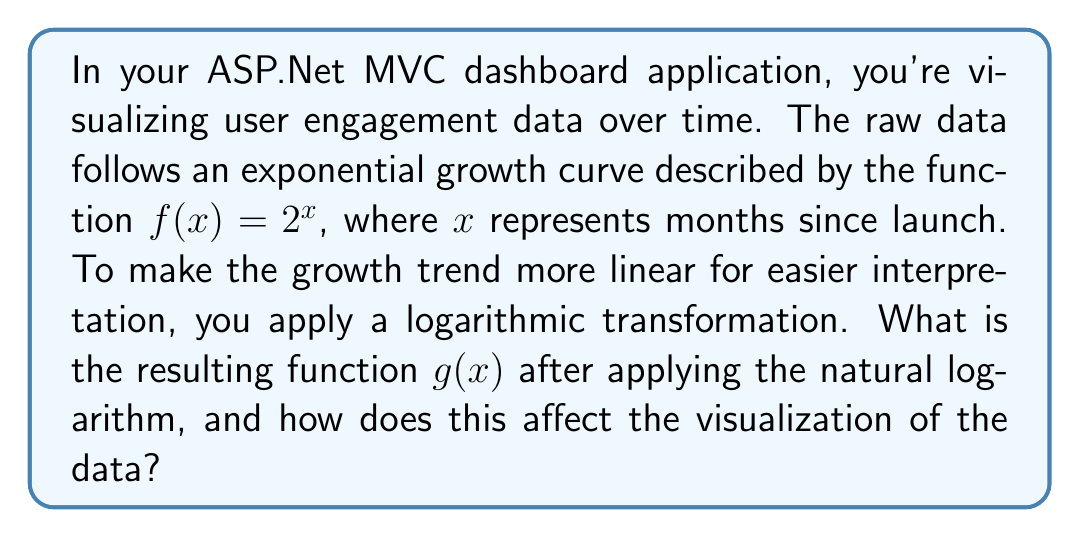Can you solve this math problem? To solve this problem, we'll follow these steps:

1) The original function is $f(x) = 2^x$

2) We want to apply the natural logarithm (ln) to this function. Remember, ln and e are inverse functions, so:

   $g(x) = \ln(f(x)) = \ln(2^x)$

3) Using the logarithm property $\ln(a^b) = b\ln(a)$, we can simplify:

   $g(x) = \ln(2^x) = x\ln(2)$

4) $\ln(2)$ is a constant (approximately 0.693), so $g(x)$ is a linear function.

5) Effect on visualization:
   - The original exponential curve $f(x) = 2^x$ would show rapid, accelerating growth.
   - The transformed function $g(x) = x\ln(2)$ will appear as a straight line.
   - This makes it easier to interpret the rate of growth, as the slope of the line is constant.
   - The y-axis will now represent the natural log of the original values.

6) In the context of the dashboard:
   - The transformation makes it easier to spot deviations from the expected growth trend.
   - Linear trends are often more intuitive for users to understand.
   - However, the actual values are now in log scale, which may require explanation for non-technical users.
Answer: The resulting function after applying the natural logarithm transformation is $g(x) = x\ln(2)$. This transforms the original exponential curve into a linear function, making the growth trend appear as a straight line in the dashboard chart, which is often easier to interpret and analyze. 